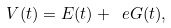<formula> <loc_0><loc_0><loc_500><loc_500>V ( t ) = E ( t ) + \ e G ( t ) ,</formula> 